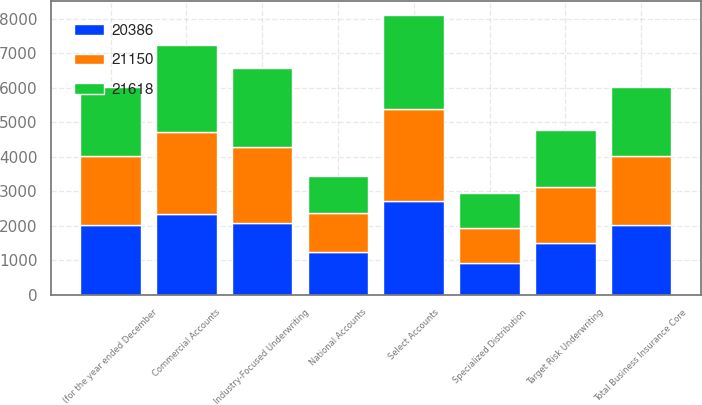Convert chart. <chart><loc_0><loc_0><loc_500><loc_500><stacked_bar_chart><ecel><fcel>(for the year ended December<fcel>Select Accounts<fcel>Commercial Accounts<fcel>National Accounts<fcel>Industry-Focused Underwriting<fcel>Target Risk Underwriting<fcel>Specialized Distribution<fcel>Total Business Insurance Core<nl><fcel>21618<fcel>2007<fcel>2711<fcel>2518<fcel>1056<fcel>2301<fcel>1665<fcel>1015<fcel>2006<nl><fcel>21150<fcel>2006<fcel>2663<fcel>2376<fcel>1135<fcel>2196<fcel>1629<fcel>1022<fcel>2006<nl><fcel>20386<fcel>2005<fcel>2722<fcel>2330<fcel>1230<fcel>2080<fcel>1482<fcel>908<fcel>2006<nl></chart> 